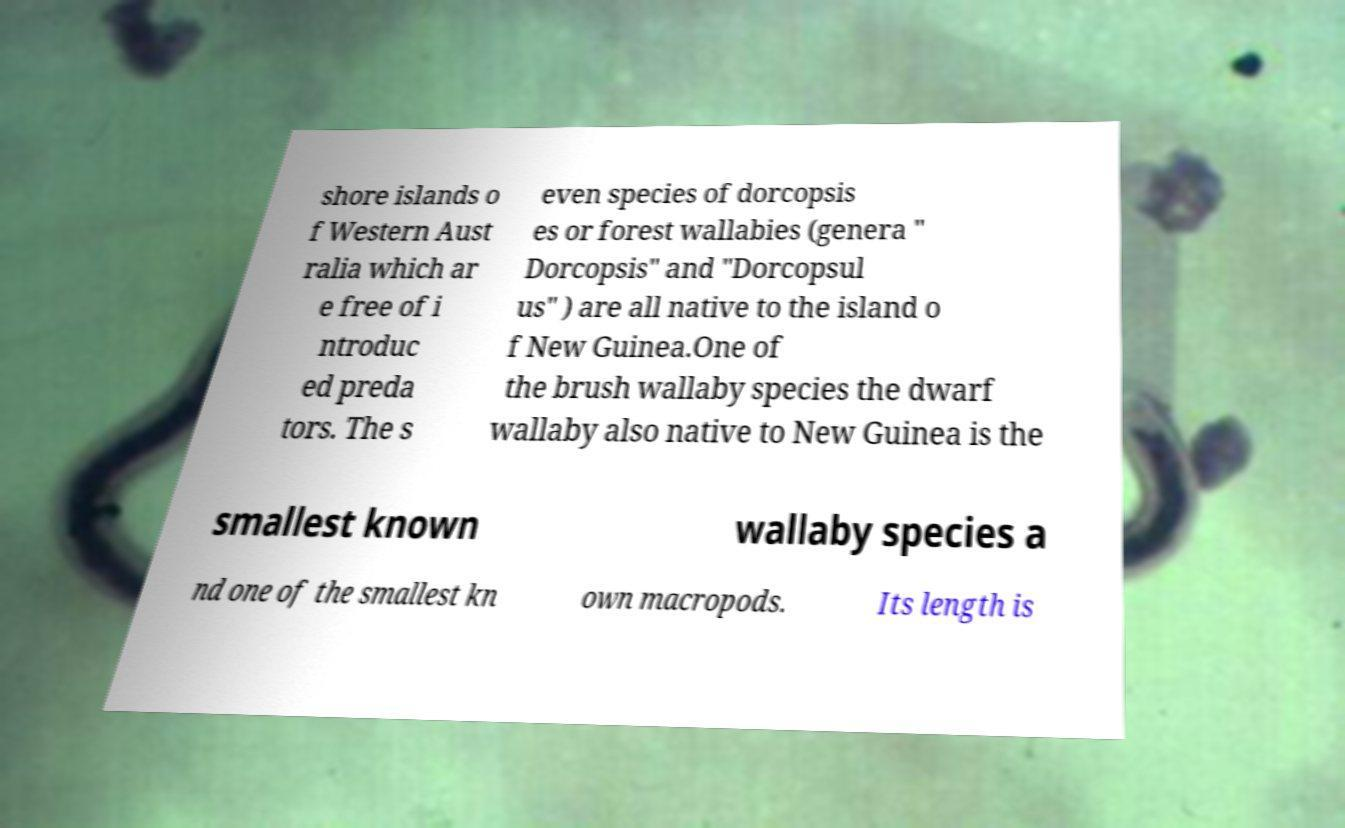Please identify and transcribe the text found in this image. shore islands o f Western Aust ralia which ar e free of i ntroduc ed preda tors. The s even species of dorcopsis es or forest wallabies (genera " Dorcopsis" and "Dorcopsul us" ) are all native to the island o f New Guinea.One of the brush wallaby species the dwarf wallaby also native to New Guinea is the smallest known wallaby species a nd one of the smallest kn own macropods. Its length is 